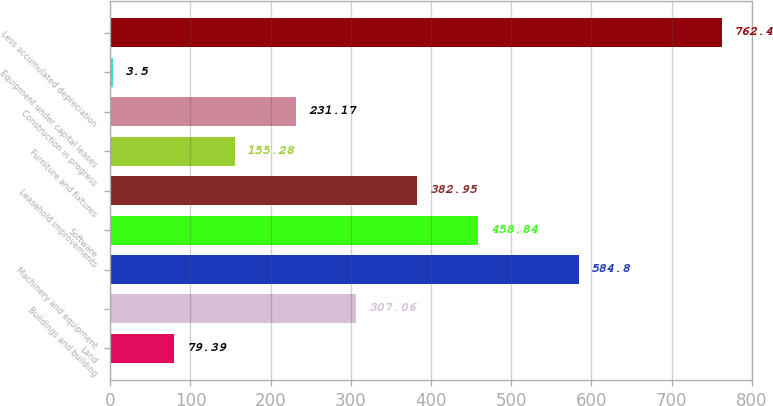Convert chart. <chart><loc_0><loc_0><loc_500><loc_500><bar_chart><fcel>Land<fcel>Buildings and building<fcel>Machinery and equipment<fcel>Software<fcel>Leasehold improvements<fcel>Furniture and fixtures<fcel>Construction in progress<fcel>Equipment under capital leases<fcel>Less accumulated depreciation<nl><fcel>79.39<fcel>307.06<fcel>584.8<fcel>458.84<fcel>382.95<fcel>155.28<fcel>231.17<fcel>3.5<fcel>762.4<nl></chart> 